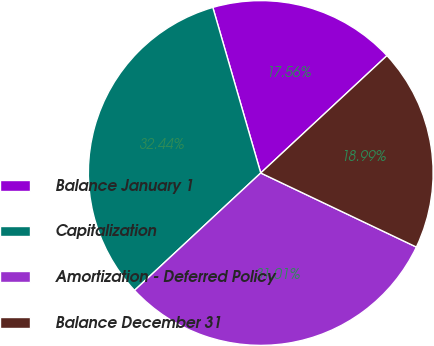<chart> <loc_0><loc_0><loc_500><loc_500><pie_chart><fcel>Balance January 1<fcel>Capitalization<fcel>Amortization - Deferred Policy<fcel>Balance December 31<nl><fcel>17.56%<fcel>32.44%<fcel>31.01%<fcel>18.99%<nl></chart> 